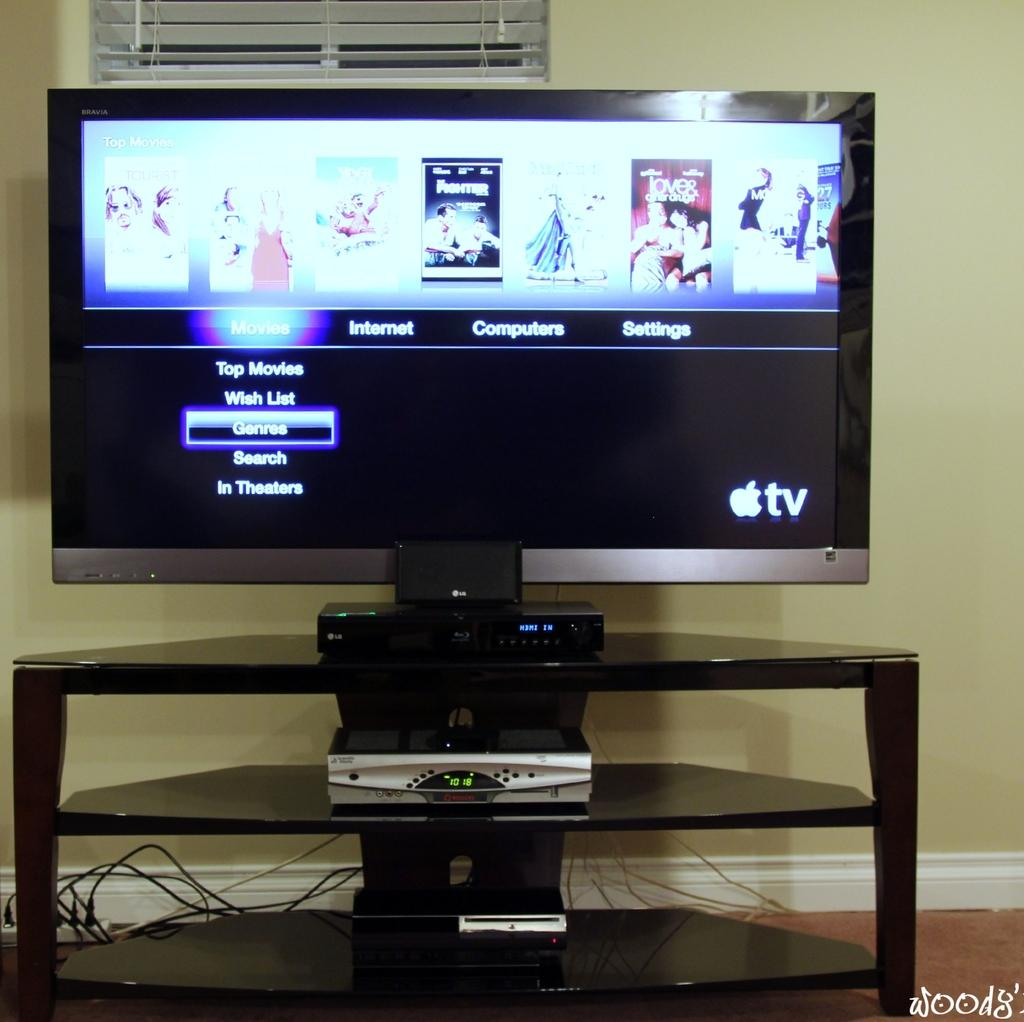<image>
Share a concise interpretation of the image provided. A flat screen TV says Movies, Internet, Computers, and Settings. 